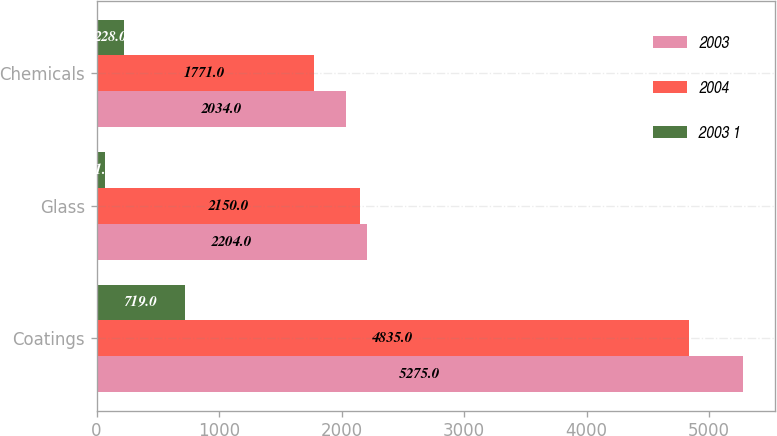Convert chart to OTSL. <chart><loc_0><loc_0><loc_500><loc_500><stacked_bar_chart><ecel><fcel>Coatings<fcel>Glass<fcel>Chemicals<nl><fcel>2003<fcel>5275<fcel>2204<fcel>2034<nl><fcel>2004<fcel>4835<fcel>2150<fcel>1771<nl><fcel>2003 1<fcel>719<fcel>71<fcel>228<nl></chart> 